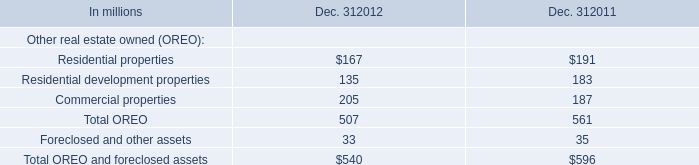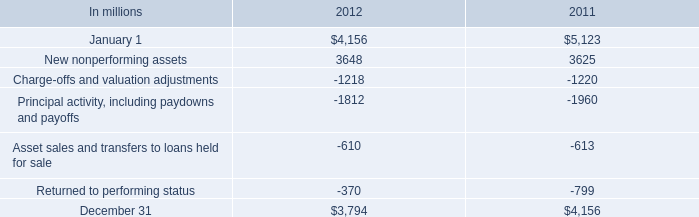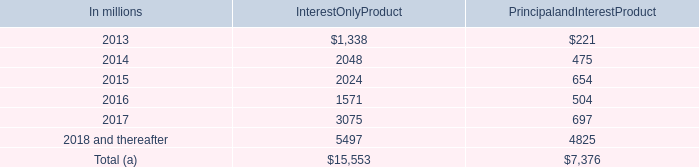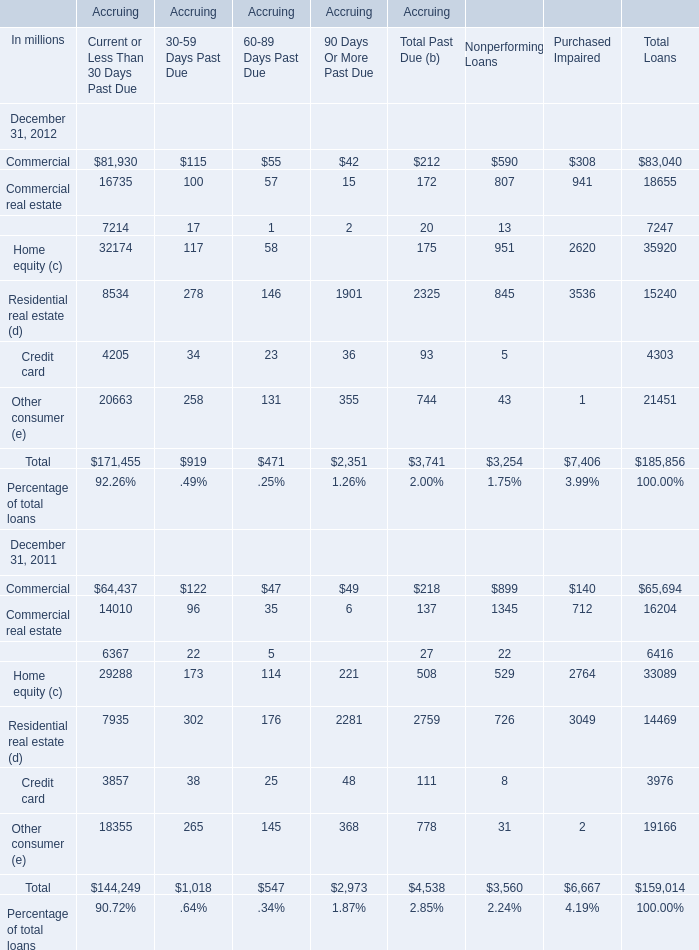in millions , what is the total of home equity lines of credit? 
Computations: (15553 + 7376)
Answer: 22929.0. 